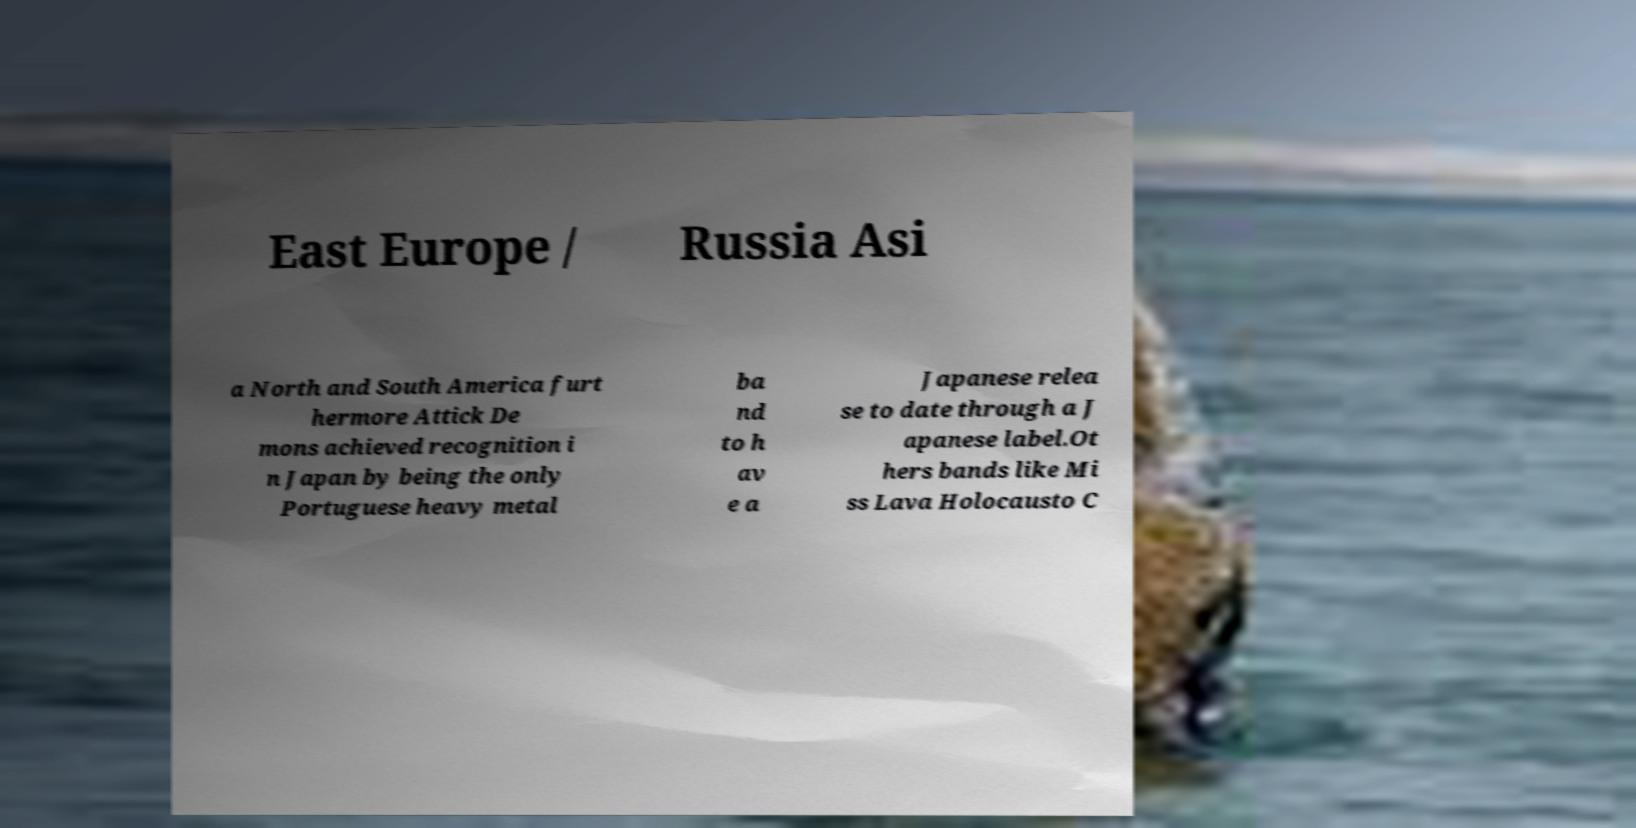Can you read and provide the text displayed in the image?This photo seems to have some interesting text. Can you extract and type it out for me? East Europe / Russia Asi a North and South America furt hermore Attick De mons achieved recognition i n Japan by being the only Portuguese heavy metal ba nd to h av e a Japanese relea se to date through a J apanese label.Ot hers bands like Mi ss Lava Holocausto C 